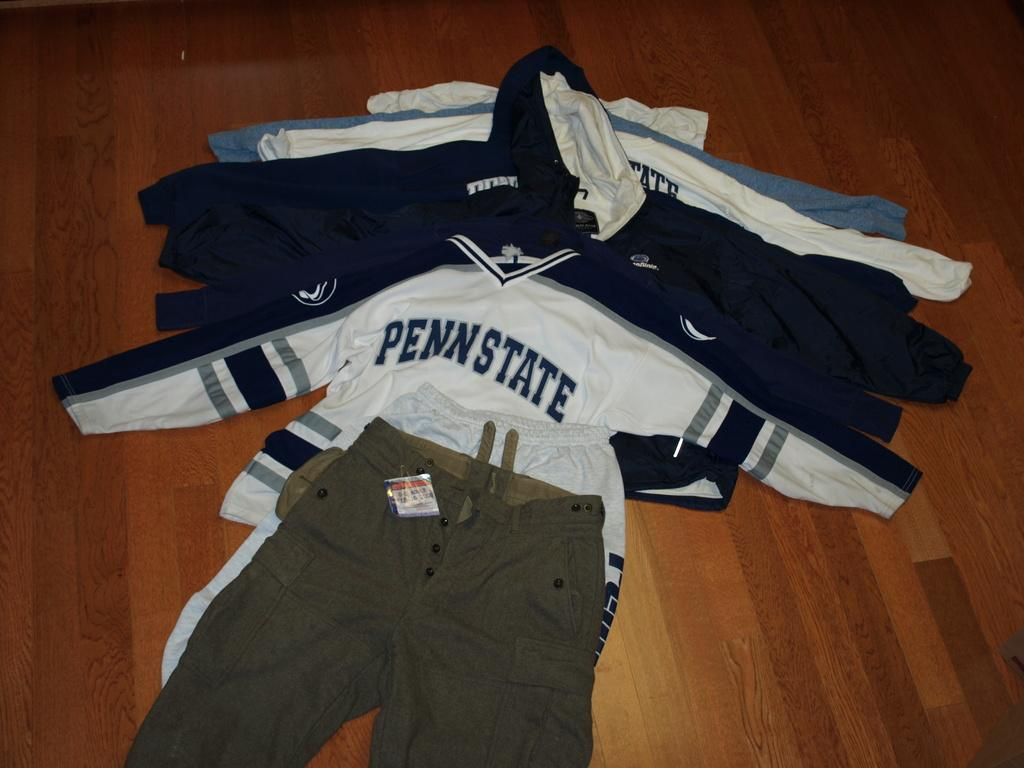Provide a one-sentence caption for the provided image. All the Penn State long-sleeved shirts are spread out underneath a pair of khaki cargo pants. 